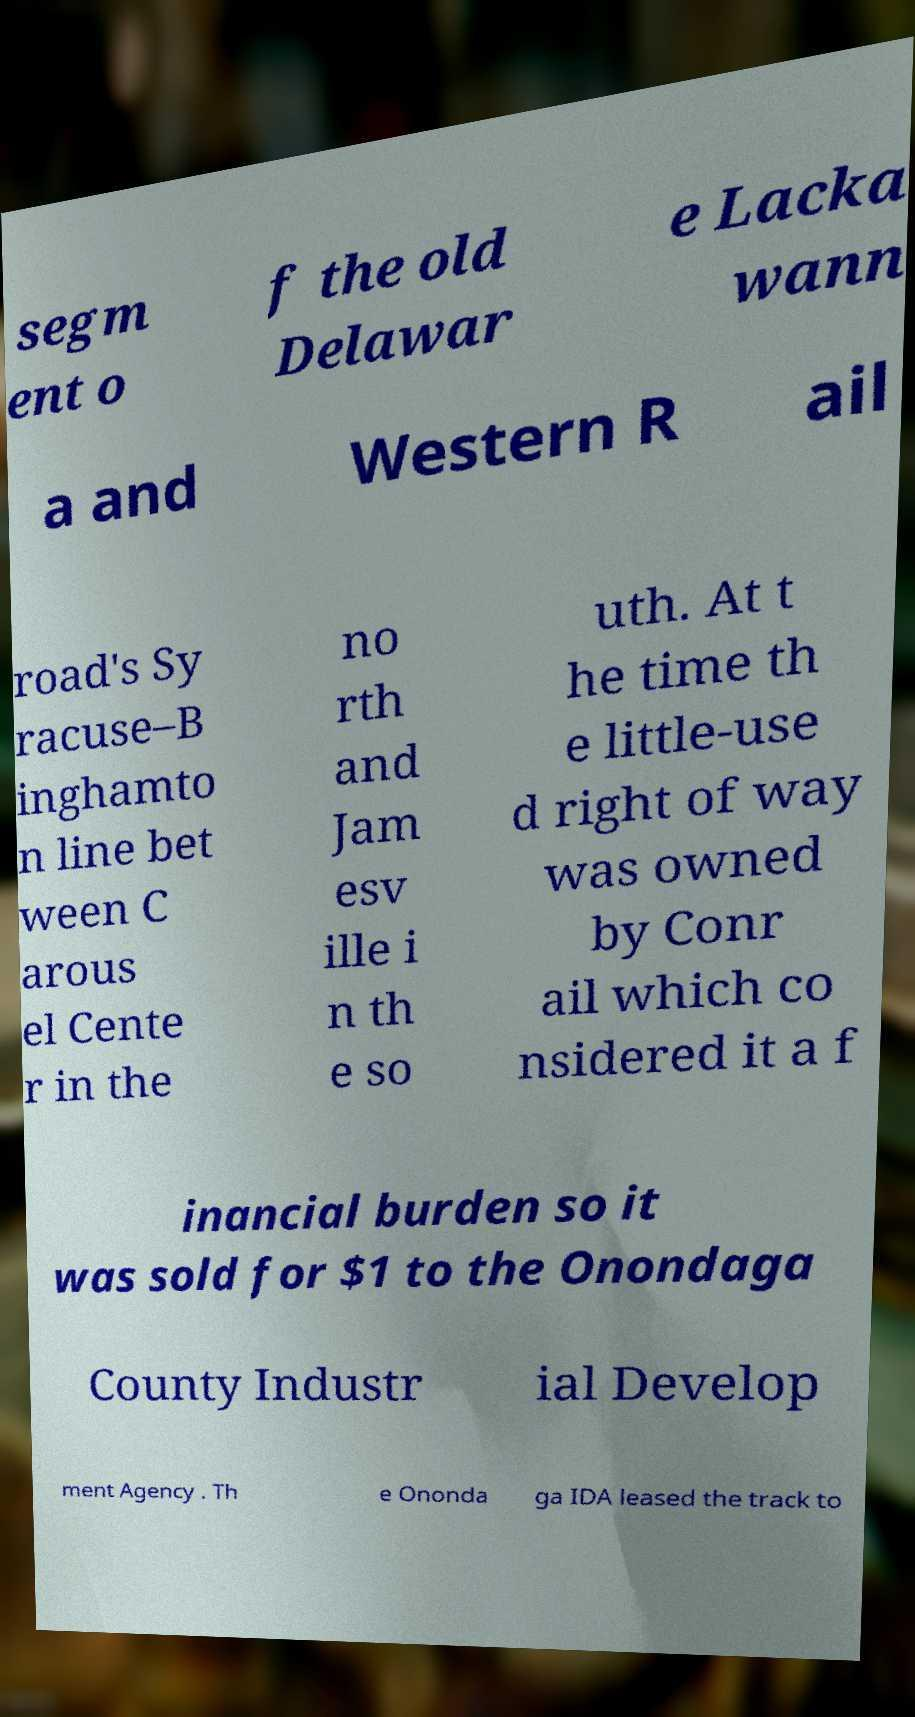Can you read and provide the text displayed in the image?This photo seems to have some interesting text. Can you extract and type it out for me? segm ent o f the old Delawar e Lacka wann a and Western R ail road's Sy racuse–B inghamto n line bet ween C arous el Cente r in the no rth and Jam esv ille i n th e so uth. At t he time th e little-use d right of way was owned by Conr ail which co nsidered it a f inancial burden so it was sold for $1 to the Onondaga County Industr ial Develop ment Agency . Th e Ononda ga IDA leased the track to 